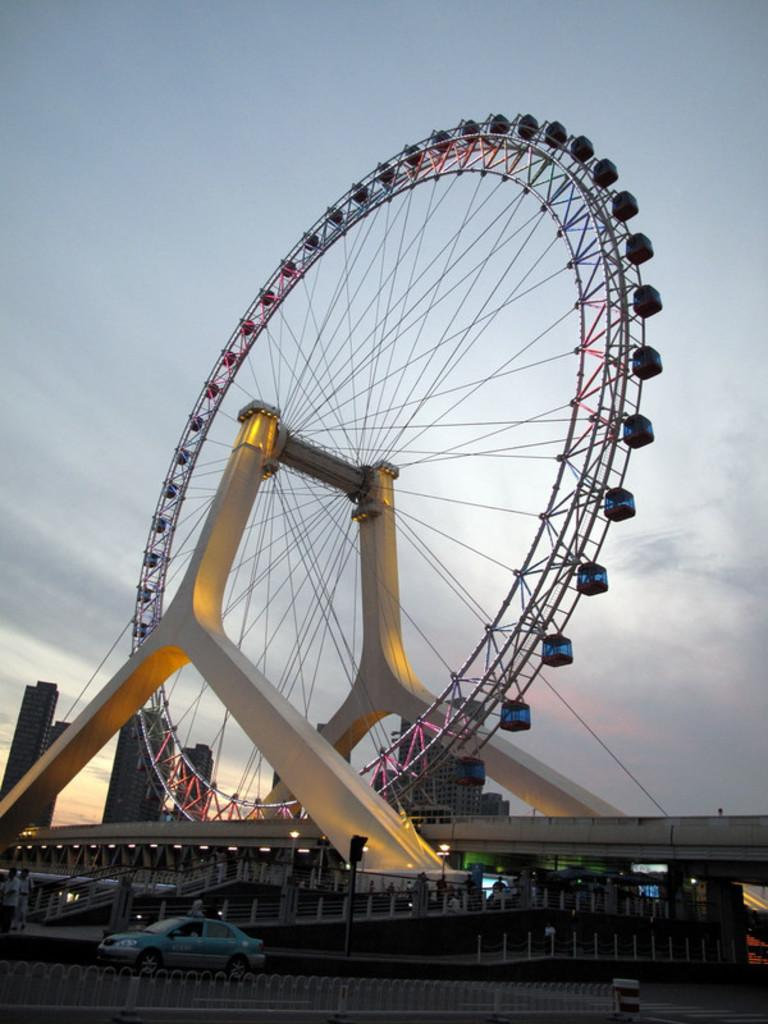What type of vehicle is in the image? There is a giant wheel vehicle in the image. Can you describe the people in the image? There are people in the image, but their specific actions or characteristics are not mentioned in the facts. What is the purpose of the fence in the image? The purpose of the fence in the image is not mentioned in the facts. What type of lighting is present in the image? There are lights in the image, but their specific type or purpose is not mentioned in the facts. What type of structures can be seen in the image? There are buildings in the image, but their specific characteristics or functions are not mentioned in the facts. What other objects are present in the image? There are other objects in the image, but their specific types or characteristics are not mentioned in the facts. What can be seen in the background of the image? The sky is visible in the background of the image. What type of house does the brother live in, as seen in the image? There is no mention of a brother or a house in the image, so this question cannot be answered definitively. 